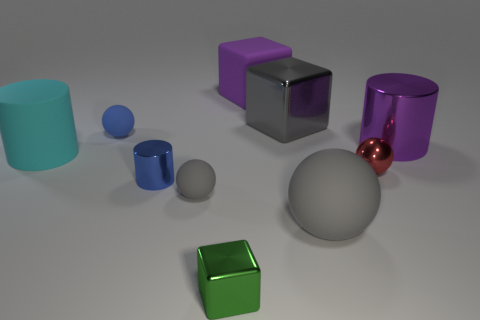Among the objects presented, is there one that seems different from the others based on its surface properties, and if so, how? Yes, the red-brown ball at the far right is distinct among the objects due to its glossy, reflective surface that both reflects the environment and appears almost glass-like, different from the more matte surfaces of the other objects. Can you hypothesize about the material of the red-brown ball? Given its highly reflective quality and transparency, the red-brown ball could be made of polished glass or a crystalline material. 